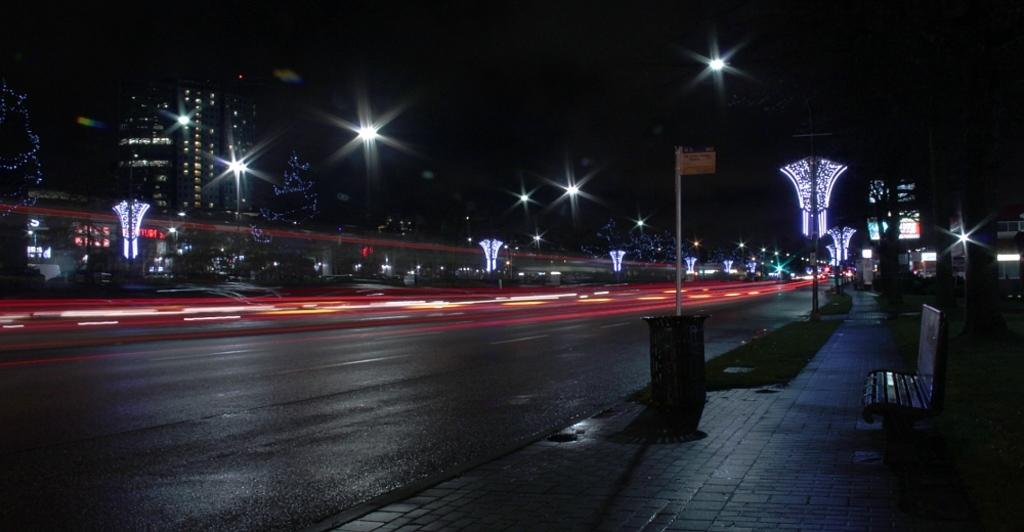What type of surface can be seen in the image? There is a road in the image. What structures are present along the road? There are poles and lights in the image. What type of structures can be seen in the background? There are buildings in the image. What type of seating is available in the image? There is a bench in the image. What type of vegetation is present in the image? There is grass in the image. What type of signage is present in the image? There is a board in the image. What type of metal can be seen in the image? There is no specific type of metal mentioned in the image. What type of bodily fluid is present in the image? There is no bodily fluid present in the image. What type of facial feature is visible in the image? There is no facial feature visible in the image. 